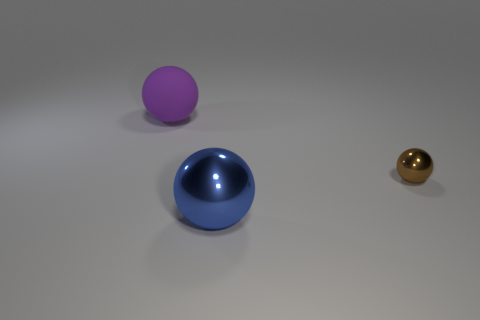How does the lighting in the image affect the appearance of the objects? The lighting from above creates subtle shadows beneath the balls, highlighting their round shape and glossy texture. It also reflects off the surfaces, with the bright spot on the blue ball indicating a smoother finish compared to the matte texture of the purple ball. 